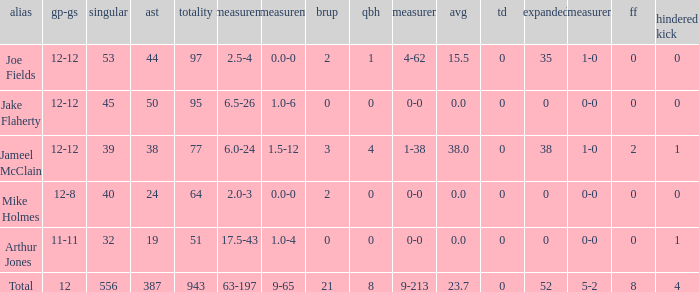How many tackle assists for the athlete who averages 2 387.0. 